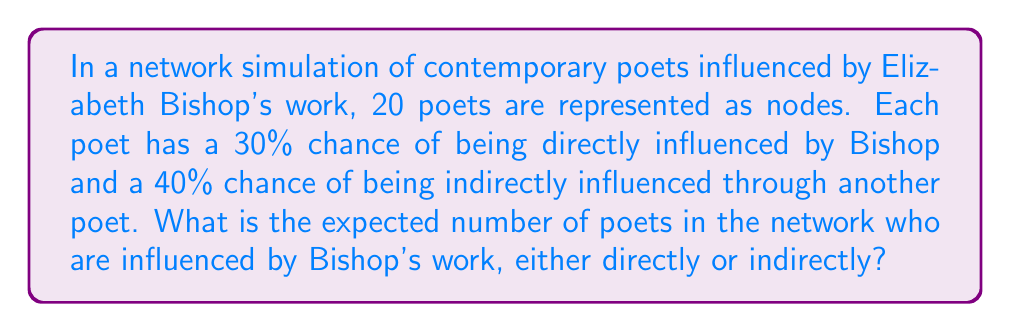Can you solve this math problem? Let's approach this step-by-step:

1) First, let's calculate the probability of a poet being influenced by Bishop, either directly or indirectly:

   $P(\text{influenced}) = P(\text{direct}) + P(\text{indirect}) - P(\text{direct and indirect})$
   
   $P(\text{influenced}) = 0.3 + 0.4 - (0.3 * 0.4) = 0.3 + 0.4 - 0.12 = 0.58$

2) Now, we can model this as a binomial distribution. In a binomial distribution, the expected value is given by $n * p$, where $n$ is the number of trials (in this case, the number of poets) and $p$ is the probability of success (in this case, the probability of being influenced).

3) Therefore, the expected number of influenced poets is:

   $E(\text{influenced poets}) = n * p = 20 * 0.58 = 11.6$

This means that, on average, we would expect 11.6 poets in the network to be influenced by Bishop's work, either directly or indirectly.
Answer: 11.6 poets 